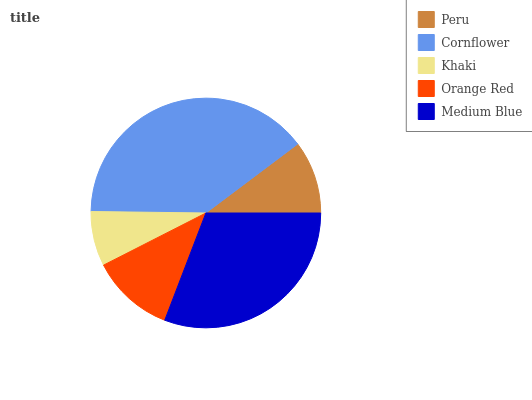Is Khaki the minimum?
Answer yes or no. Yes. Is Cornflower the maximum?
Answer yes or no. Yes. Is Cornflower the minimum?
Answer yes or no. No. Is Khaki the maximum?
Answer yes or no. No. Is Cornflower greater than Khaki?
Answer yes or no. Yes. Is Khaki less than Cornflower?
Answer yes or no. Yes. Is Khaki greater than Cornflower?
Answer yes or no. No. Is Cornflower less than Khaki?
Answer yes or no. No. Is Orange Red the high median?
Answer yes or no. Yes. Is Orange Red the low median?
Answer yes or no. Yes. Is Peru the high median?
Answer yes or no. No. Is Khaki the low median?
Answer yes or no. No. 